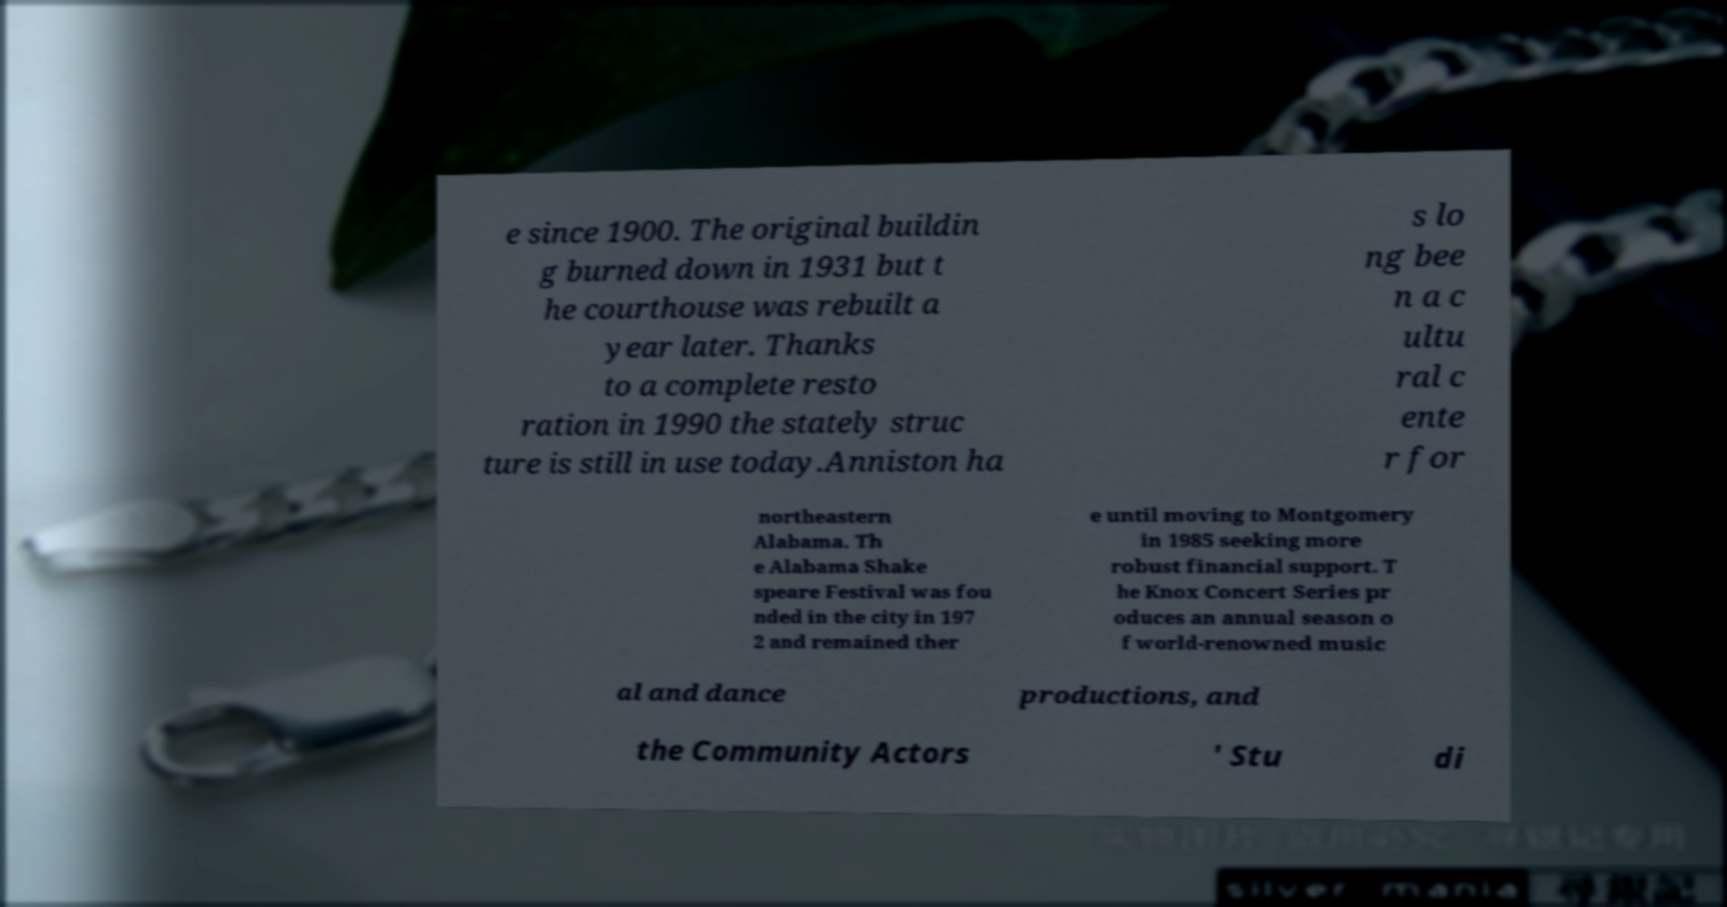Please read and relay the text visible in this image. What does it say? e since 1900. The original buildin g burned down in 1931 but t he courthouse was rebuilt a year later. Thanks to a complete resto ration in 1990 the stately struc ture is still in use today.Anniston ha s lo ng bee n a c ultu ral c ente r for northeastern Alabama. Th e Alabama Shake speare Festival was fou nded in the city in 197 2 and remained ther e until moving to Montgomery in 1985 seeking more robust financial support. T he Knox Concert Series pr oduces an annual season o f world-renowned music al and dance productions, and the Community Actors ' Stu di 